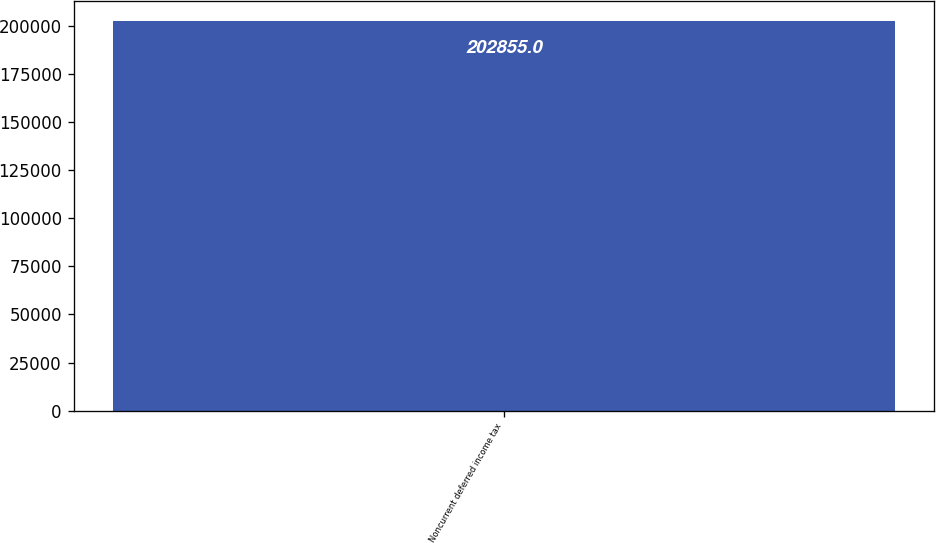Convert chart. <chart><loc_0><loc_0><loc_500><loc_500><bar_chart><fcel>Noncurrent deferred income tax<nl><fcel>202855<nl></chart> 